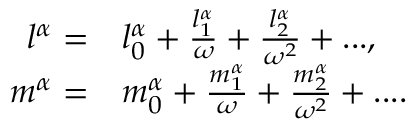Convert formula to latex. <formula><loc_0><loc_0><loc_500><loc_500>\begin{array} { r l } { l ^ { \alpha } = } & l _ { 0 } ^ { \alpha } + \frac { l _ { 1 } ^ { \alpha } } { \omega } + \frac { l _ { 2 } ^ { \alpha } } { \omega ^ { 2 } } + \dots , } \\ { m ^ { \alpha } = } & m _ { 0 } ^ { \alpha } + \frac { m _ { 1 } ^ { \alpha } } { \omega } + \frac { m _ { 2 } ^ { \alpha } } { \omega ^ { 2 } } + \cdots } \end{array}</formula> 